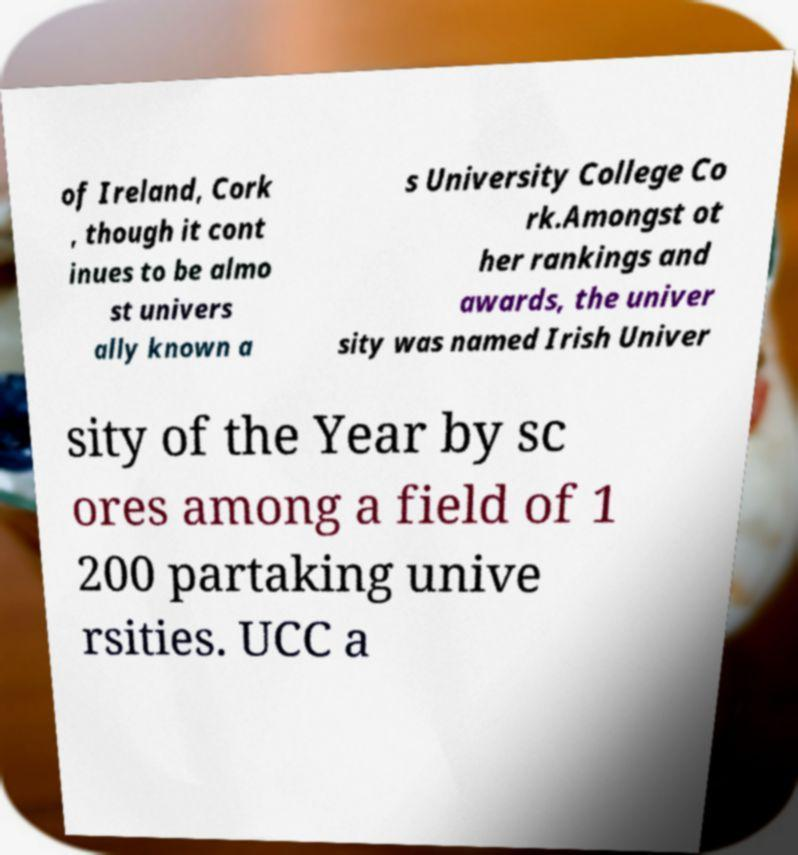Could you extract and type out the text from this image? of Ireland, Cork , though it cont inues to be almo st univers ally known a s University College Co rk.Amongst ot her rankings and awards, the univer sity was named Irish Univer sity of the Year by sc ores among a field of 1 200 partaking unive rsities. UCC a 